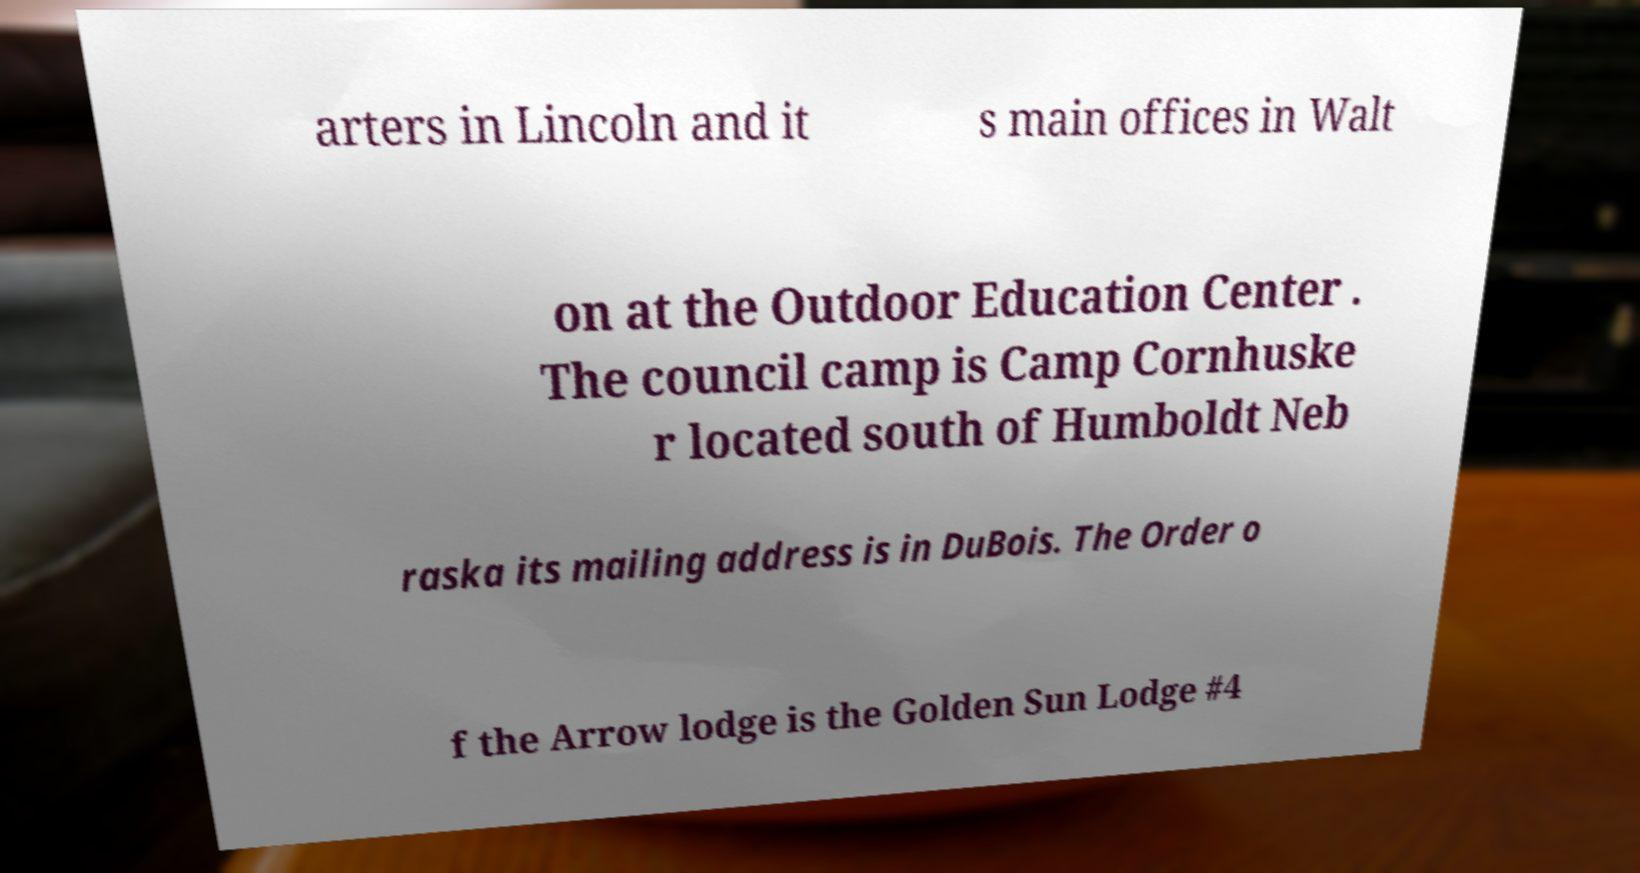What messages or text are displayed in this image? I need them in a readable, typed format. arters in Lincoln and it s main offices in Walt on at the Outdoor Education Center . The council camp is Camp Cornhuske r located south of Humboldt Neb raska its mailing address is in DuBois. The Order o f the Arrow lodge is the Golden Sun Lodge #4 